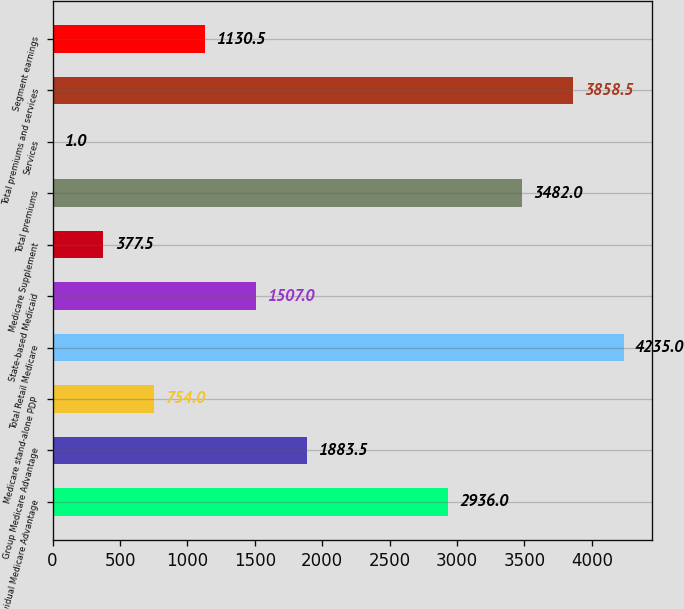<chart> <loc_0><loc_0><loc_500><loc_500><bar_chart><fcel>Individual Medicare Advantage<fcel>Group Medicare Advantage<fcel>Medicare stand-alone PDP<fcel>Total Retail Medicare<fcel>State-based Medicaid<fcel>Medicare Supplement<fcel>Total premiums<fcel>Services<fcel>Total premiums and services<fcel>Segment earnings<nl><fcel>2936<fcel>1883.5<fcel>754<fcel>4235<fcel>1507<fcel>377.5<fcel>3482<fcel>1<fcel>3858.5<fcel>1130.5<nl></chart> 